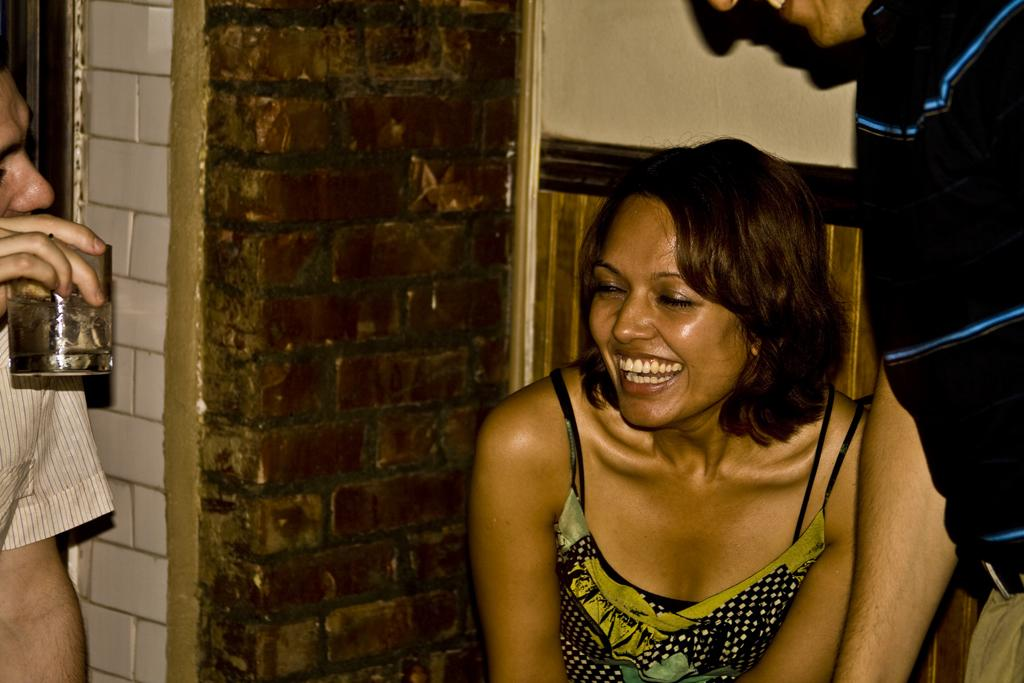How many people are present in the image? There are three people in the image. What is one of the people holding in his hand? A man is holding a glass in his hand. Can you describe the expressions of the people in the image? Two people are smiling. What can be seen in the background of the image? There is a wall in the background of the image. What type of song is being sung by the people in the image? There is no indication in the image that the people are singing a song, so it cannot be determined from the picture. 